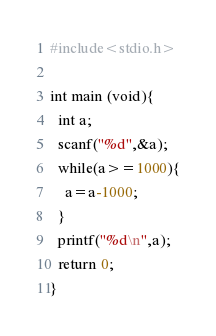Convert code to text. <code><loc_0><loc_0><loc_500><loc_500><_C_>#include<stdio.h>
 
int main (void){
  int a;
  scanf("%d",&a);
  while(a>=1000){
    a=a-1000;
  }
  printf("%d\n",a);
  return 0;
}</code> 